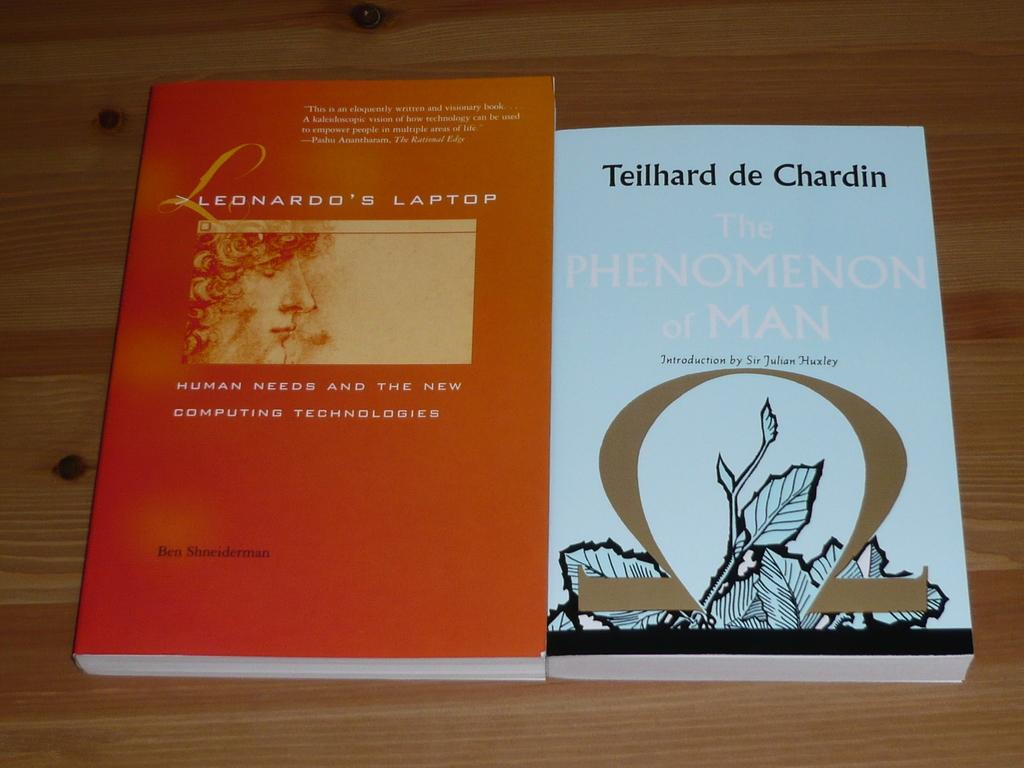Provide a one-sentence caption for the provided image. Two books sit side by side on a table, the left of which is titled Leonardo's Laptop. 